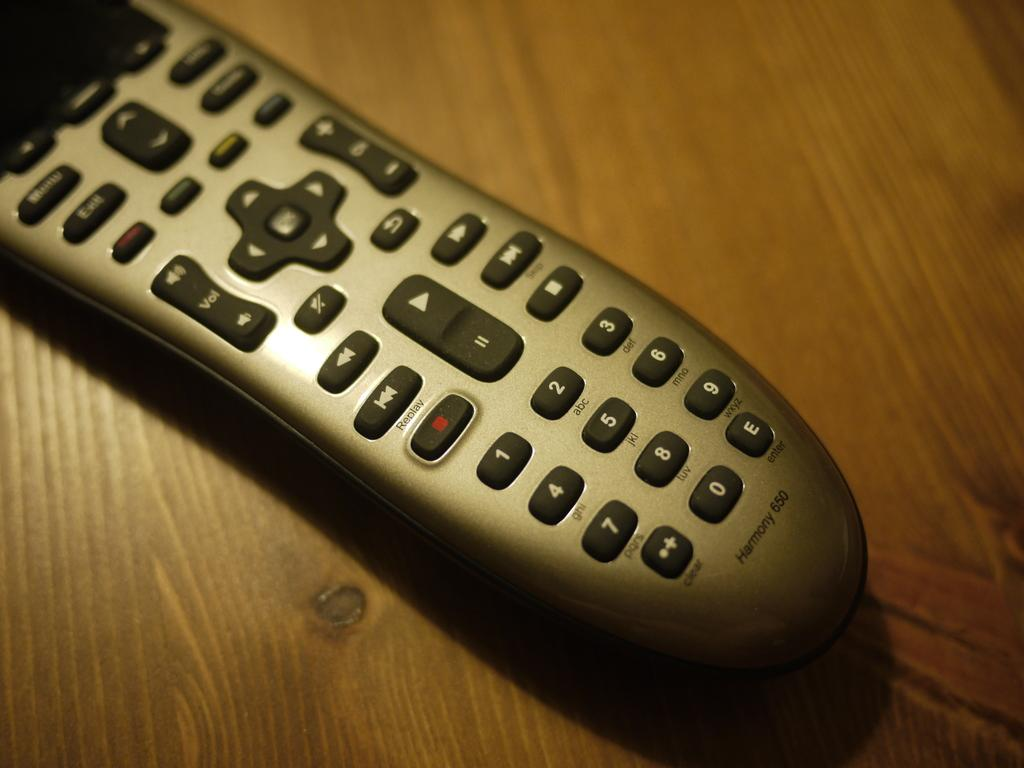<image>
Summarize the visual content of the image. A Harmony 650 remote control is laying on a wooden surface. 